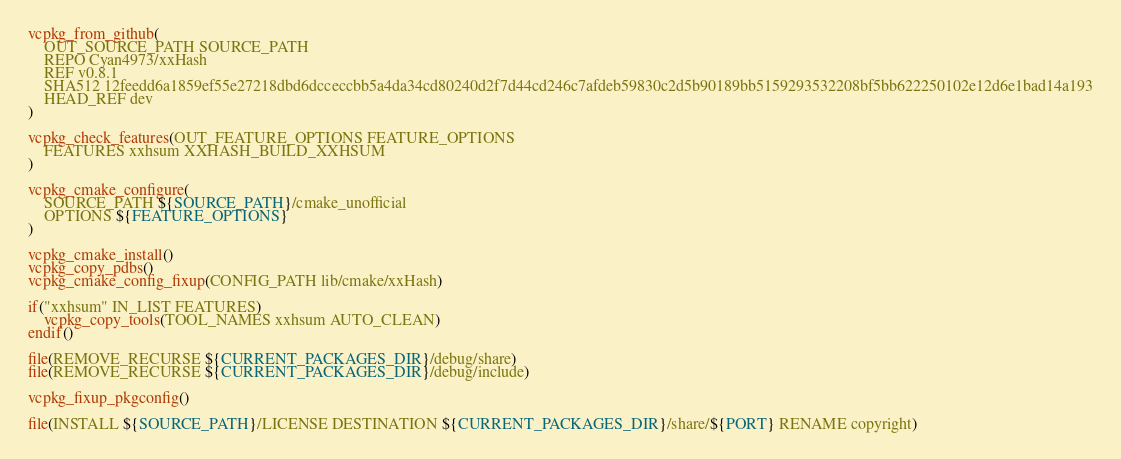Convert code to text. <code><loc_0><loc_0><loc_500><loc_500><_CMake_>vcpkg_from_github(
    OUT_SOURCE_PATH SOURCE_PATH
    REPO Cyan4973/xxHash
    REF v0.8.1
    SHA512 12feedd6a1859ef55e27218dbd6dcceccbb5a4da34cd80240d2f7d44cd246c7afdeb59830c2d5b90189bb5159293532208bf5bb622250102e12d6e1bad14a193
    HEAD_REF dev
)

vcpkg_check_features(OUT_FEATURE_OPTIONS FEATURE_OPTIONS
    FEATURES xxhsum XXHASH_BUILD_XXHSUM
)

vcpkg_cmake_configure(
    SOURCE_PATH ${SOURCE_PATH}/cmake_unofficial
    OPTIONS ${FEATURE_OPTIONS}
)

vcpkg_cmake_install()
vcpkg_copy_pdbs()
vcpkg_cmake_config_fixup(CONFIG_PATH lib/cmake/xxHash)

if("xxhsum" IN_LIST FEATURES)
    vcpkg_copy_tools(TOOL_NAMES xxhsum AUTO_CLEAN)
endif()

file(REMOVE_RECURSE ${CURRENT_PACKAGES_DIR}/debug/share)
file(REMOVE_RECURSE ${CURRENT_PACKAGES_DIR}/debug/include)

vcpkg_fixup_pkgconfig()

file(INSTALL ${SOURCE_PATH}/LICENSE DESTINATION ${CURRENT_PACKAGES_DIR}/share/${PORT} RENAME copyright)</code> 